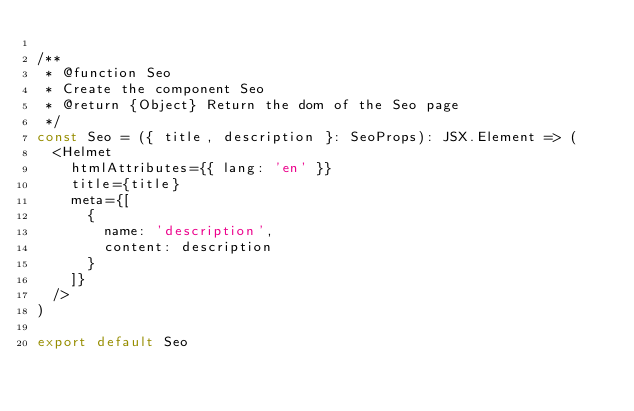Convert code to text. <code><loc_0><loc_0><loc_500><loc_500><_TypeScript_>
/**
 * @function Seo
 * Create the component Seo
 * @return {Object} Return the dom of the Seo page
 */
const Seo = ({ title, description }: SeoProps): JSX.Element => (
  <Helmet
    htmlAttributes={{ lang: 'en' }}
    title={title}
    meta={[
      {
        name: 'description',
        content: description
      }
    ]}
  />
)

export default Seo
</code> 